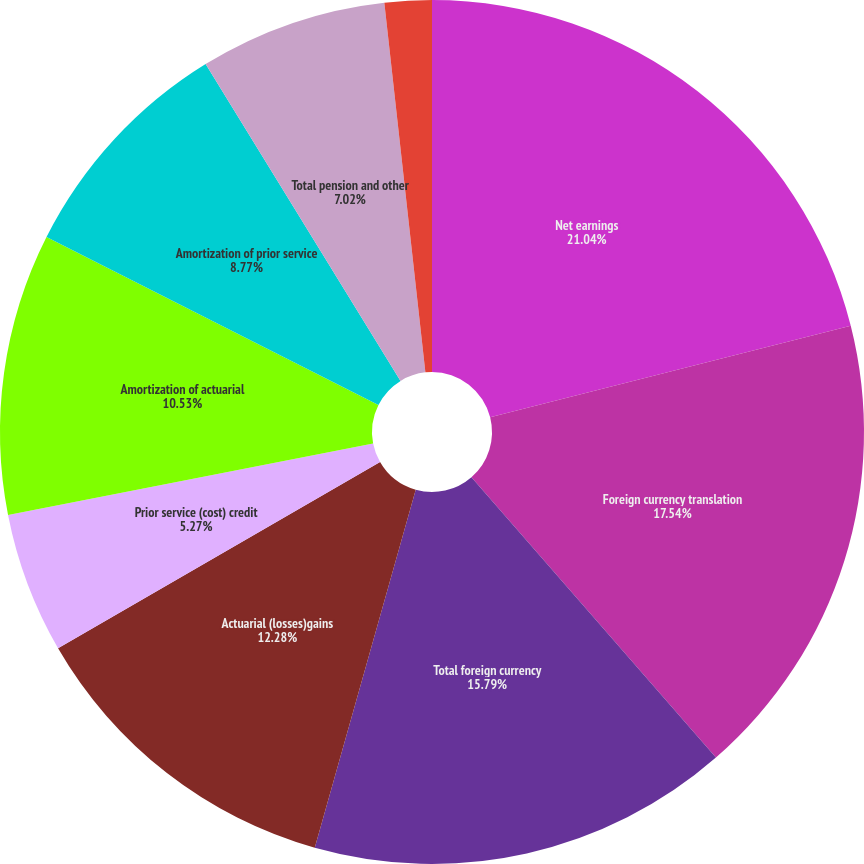Convert chart to OTSL. <chart><loc_0><loc_0><loc_500><loc_500><pie_chart><fcel>Net earnings<fcel>Foreign currency translation<fcel>Total foreign currency<fcel>Actuarial (losses)gains<fcel>Prior service (cost) credit<fcel>Amortization of actuarial<fcel>Amortization of prior service<fcel>Total pension and other<fcel>Unrealized net gains (losses)<fcel>Net losses (gains)<nl><fcel>21.05%<fcel>17.54%<fcel>15.79%<fcel>12.28%<fcel>5.27%<fcel>10.53%<fcel>8.77%<fcel>7.02%<fcel>0.0%<fcel>1.76%<nl></chart> 